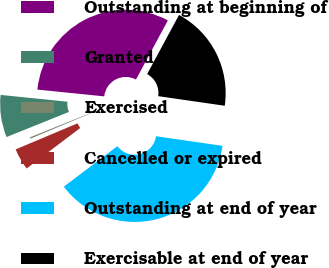<chart> <loc_0><loc_0><loc_500><loc_500><pie_chart><fcel>Outstanding at beginning of<fcel>Granted<fcel>Exercised<fcel>Cancelled or expired<fcel>Outstanding at end of year<fcel>Exercisable at end of year<nl><fcel>31.26%<fcel>7.7%<fcel>0.25%<fcel>3.96%<fcel>37.42%<fcel>19.41%<nl></chart> 